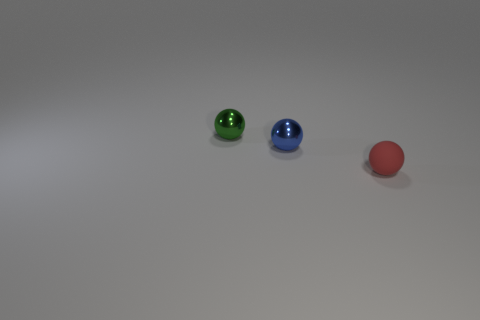What can the positioning of these objects tell us about the composition of the photograph? The placement of the objects creates a sense of progression or a narrative. The linear arrangement could indicate movement or direction, leading the viewer's eye from one object to the next and providing a dynamic quality to the composition. 